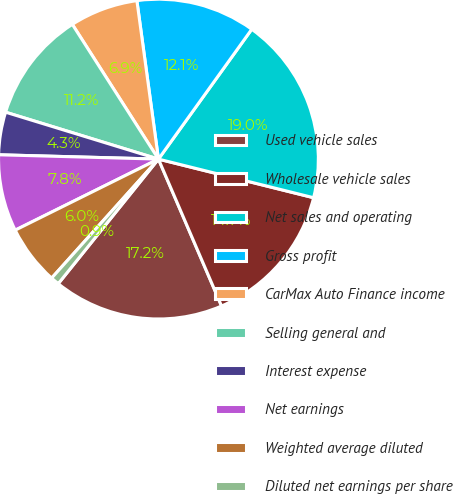Convert chart. <chart><loc_0><loc_0><loc_500><loc_500><pie_chart><fcel>Used vehicle sales<fcel>Wholesale vehicle sales<fcel>Net sales and operating<fcel>Gross profit<fcel>CarMax Auto Finance income<fcel>Selling general and<fcel>Interest expense<fcel>Net earnings<fcel>Weighted average diluted<fcel>Diluted net earnings per share<nl><fcel>17.24%<fcel>14.66%<fcel>18.97%<fcel>12.07%<fcel>6.9%<fcel>11.21%<fcel>4.31%<fcel>7.76%<fcel>6.03%<fcel>0.86%<nl></chart> 